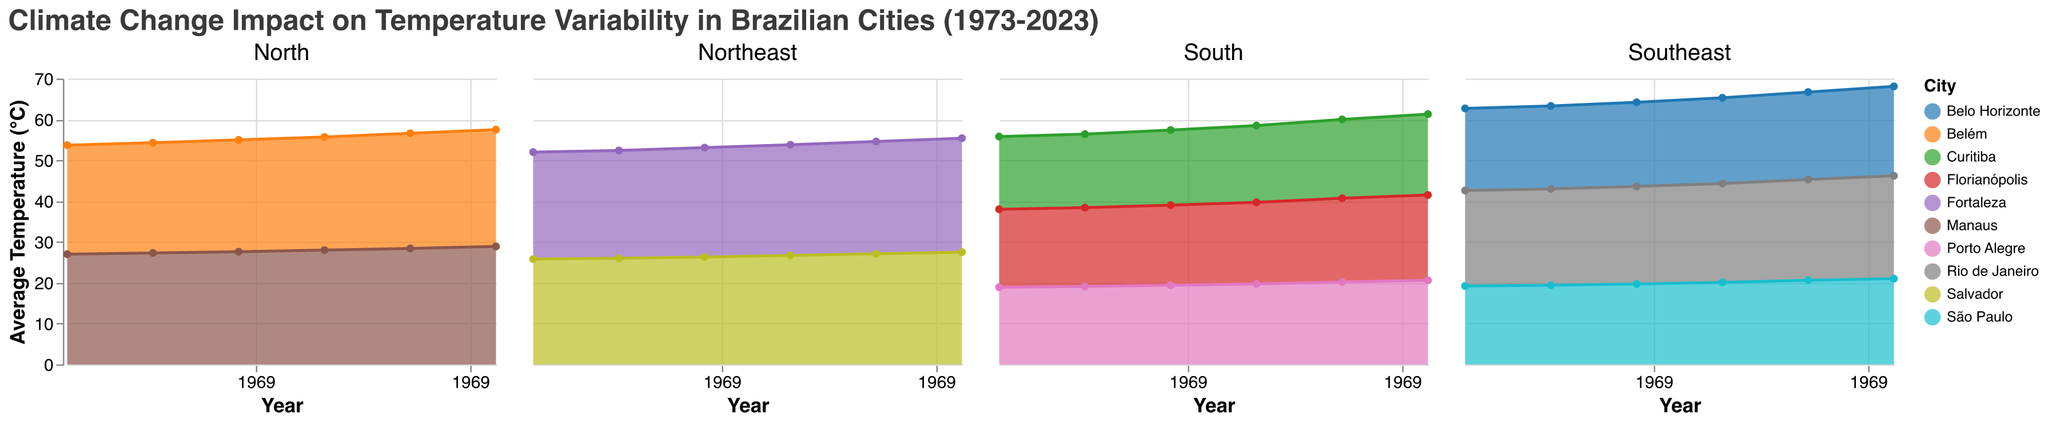What is the average temperature of São Paulo in 2023? Locate the subplot for the Southeast region, find the line representing São Paulo, and read the value at the year 2023. The temperature is 21.0°C
Answer: 21.0°C Which city in the Northeast region had the highest average temperature in 2023? Analyze the Northeast subplot and compare the average temperatures of Fortaleza and Salvador in 2023. Fortaleza has a higher temperature at 27.9°C compared to Salvador's 27.5°C
Answer: Fortaleza By how much did the average temperature in Rio de Janeiro increase from 1973 to 2023? In the Southeast subplot, find the temperature values for Rio de Janeiro in 1973 and 2023. Subtract the 1973 value (23.4°C) from the 2023 value (25.2°C): 25.2 - 23.4 = 1.8°C
Answer: 1.8°C Which region shows the highest average temperatures in 2023? Look at all the subplots for the year 2023 and compare the highest values in each region. The North region has the highest values with Manaus at 28.9°C and Belém at 28.6°C
Answer: North What is the general trend of temperature changes in Curitiba from 1973 to 2023? In the South subplot, observe the line representing Curitiba. The line shows a steady increase from 17.8°C in 1973 to 19.8°C in 2023, indicating a warming trend
Answer: Increasing What was the average temperature in Fortaleza in 1993? Locate the Northeast subplot, find the line for Fortaleza, and look up the value for the year 1993. The temperature is 26.8°C
Answer: 26.8°C Which city in the Southeast region had the largest increase in temperature from 1973 to 2023? Calculate the difference between the temperatures in 1973 and 2023 for each city in the Southeast: São Paulo (21.0 - 19.2 = 1.8°C), Rio de Janeiro (25.2 - 23.4 = 1.8°C), and Belo Horizonte (21.9 - 20.1 = 1.8°C). All three cities had the same increase of 1.8°C
Answer: São Paulo, Rio de Janeiro, Belo Horizonte (tie) Compare the temperature trends in Manaus and Belém from 1973 to 2023. Which city had a greater rate of increase? Focus on the North subplot, observe the line trends for Manaus and Belém. Calculate the differences: Manaus (28.9 - 27.0 = 1.9°C), Belém (28.6 - 26.7 = 1.9°C). Both cities show the same rate of increase
Answer: Same rate of increase How does the average temperature trend in Porto Alegre compare to that in Florianópolis? In the South subplot, compare the trends of Porto Alegre and Florianópolis lines. Both cities show an increasing trend from 1973 to 2023, but Florianópolis has slightly higher values and a steeper increase
Answer: Similar increasing trends 